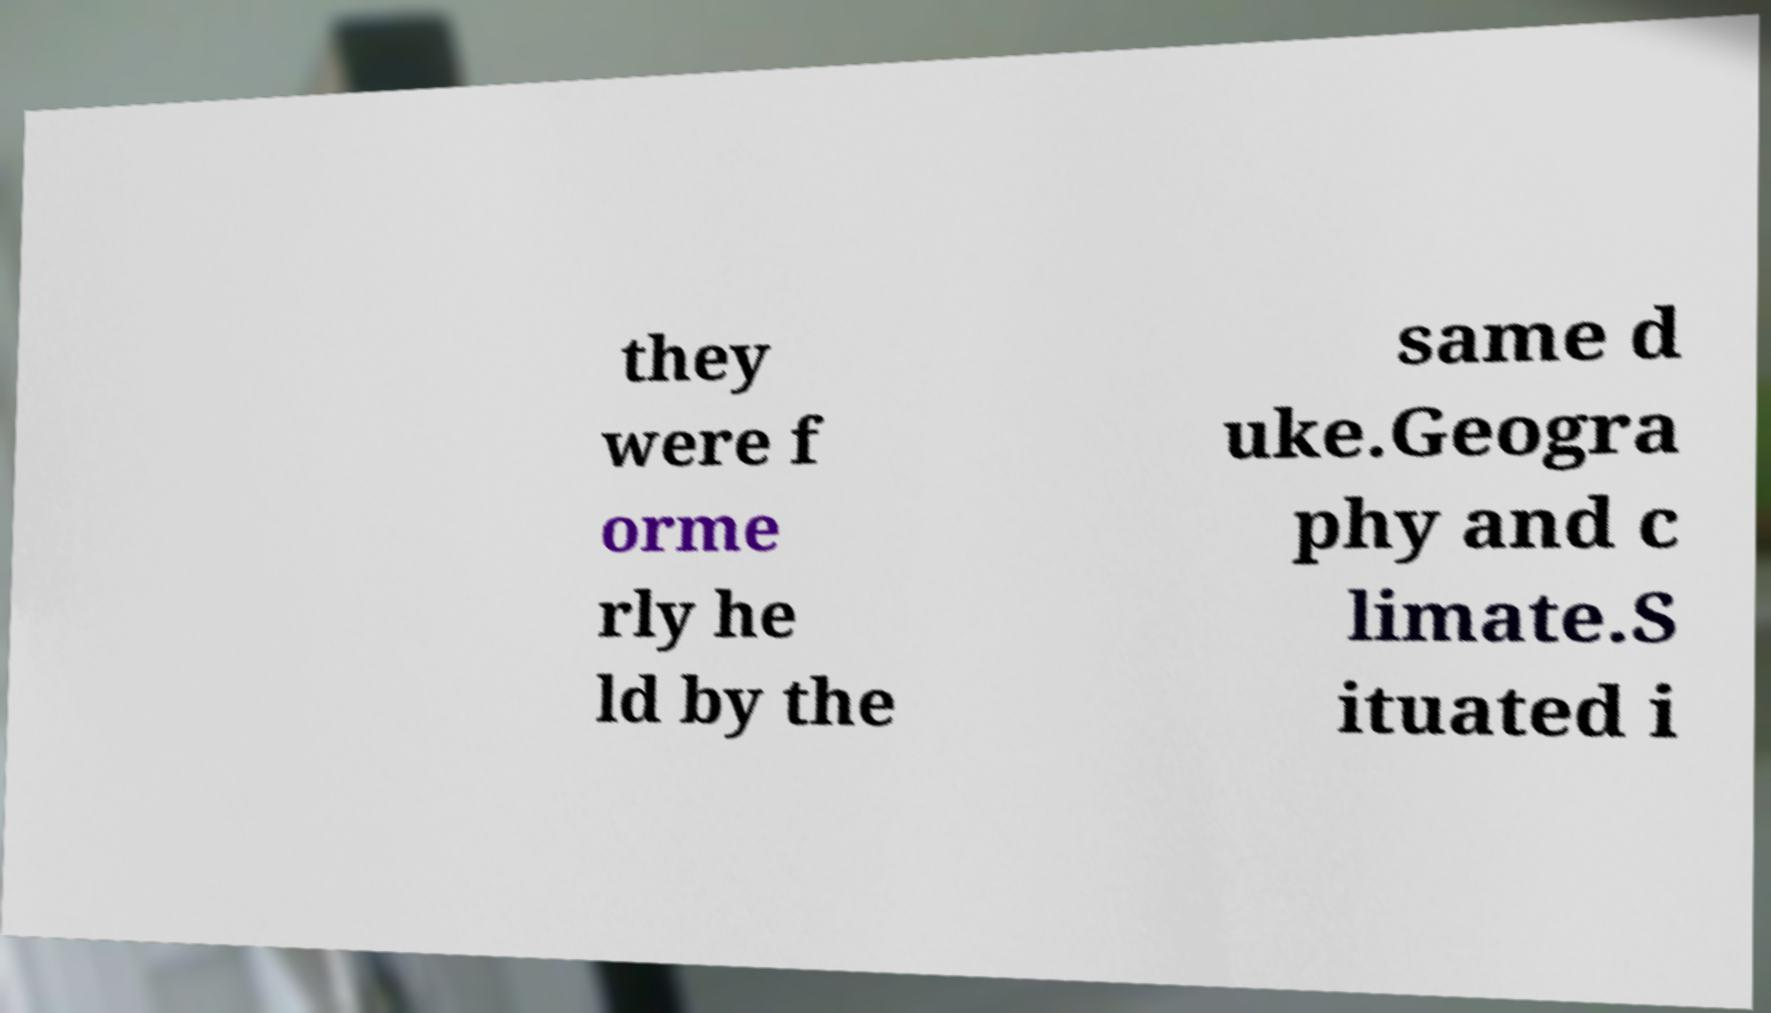There's text embedded in this image that I need extracted. Can you transcribe it verbatim? they were f orme rly he ld by the same d uke.Geogra phy and c limate.S ituated i 